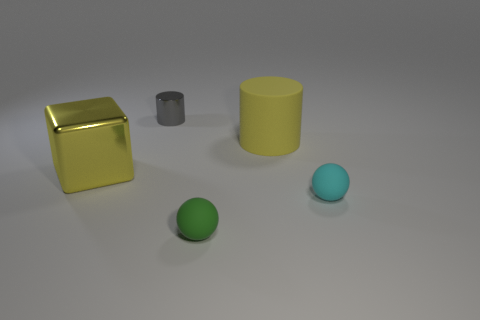Add 4 small objects. How many objects exist? 9 Subtract all cylinders. How many objects are left? 3 Add 4 yellow rubber things. How many yellow rubber things exist? 5 Subtract 0 blue blocks. How many objects are left? 5 Subtract all red matte blocks. Subtract all yellow matte things. How many objects are left? 4 Add 2 large yellow objects. How many large yellow objects are left? 4 